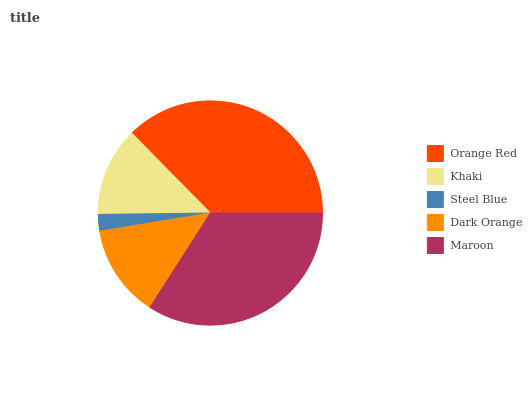Is Steel Blue the minimum?
Answer yes or no. Yes. Is Orange Red the maximum?
Answer yes or no. Yes. Is Khaki the minimum?
Answer yes or no. No. Is Khaki the maximum?
Answer yes or no. No. Is Orange Red greater than Khaki?
Answer yes or no. Yes. Is Khaki less than Orange Red?
Answer yes or no. Yes. Is Khaki greater than Orange Red?
Answer yes or no. No. Is Orange Red less than Khaki?
Answer yes or no. No. Is Dark Orange the high median?
Answer yes or no. Yes. Is Dark Orange the low median?
Answer yes or no. Yes. Is Steel Blue the high median?
Answer yes or no. No. Is Khaki the low median?
Answer yes or no. No. 